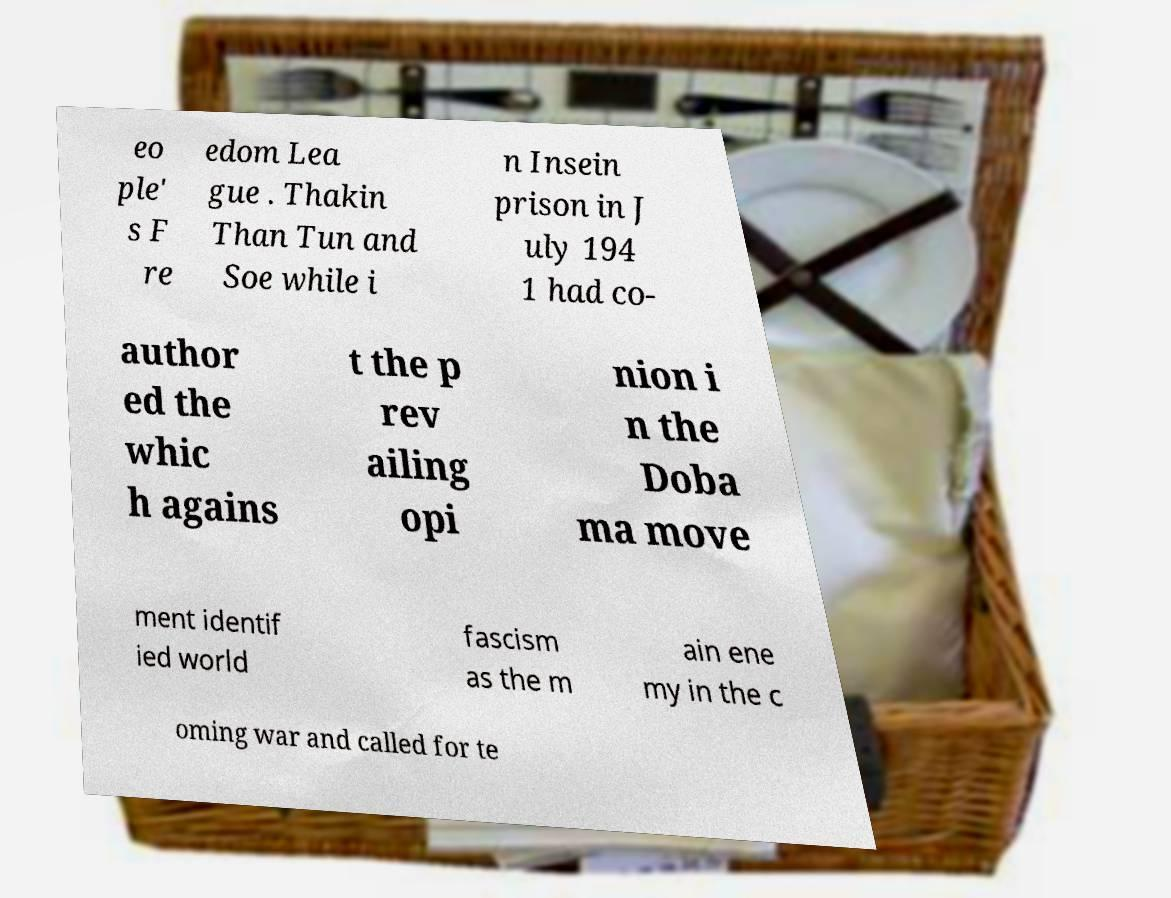Can you accurately transcribe the text from the provided image for me? eo ple' s F re edom Lea gue . Thakin Than Tun and Soe while i n Insein prison in J uly 194 1 had co- author ed the whic h agains t the p rev ailing opi nion i n the Doba ma move ment identif ied world fascism as the m ain ene my in the c oming war and called for te 